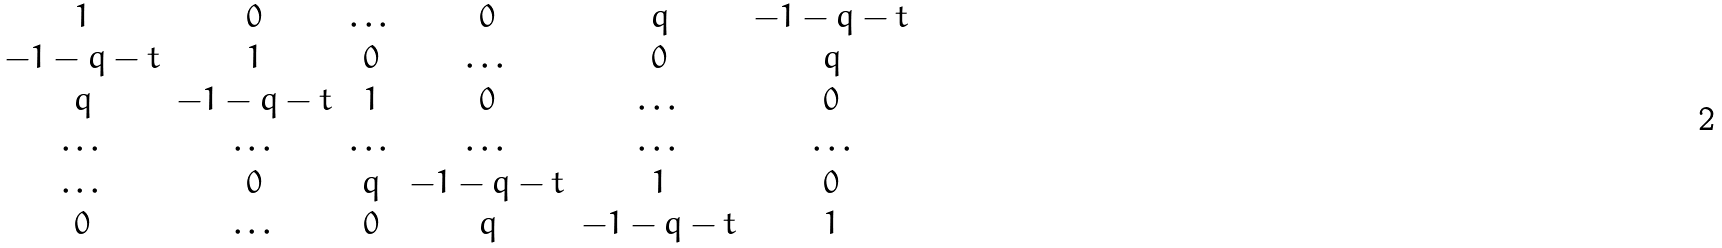<formula> <loc_0><loc_0><loc_500><loc_500>\begin{matrix} 1 & 0 & \dots & 0 & q & - 1 - q - t \\ - 1 - q - t & 1 & 0 & \dots & 0 & q \\ q & - 1 - q - t & 1 & 0 & \dots & 0 \\ \dots & \dots & \dots & \dots & \dots & \dots \\ \dots & 0 & q & - 1 - q - t & 1 & 0 \\ 0 & \dots & 0 & q & - 1 - q - t & 1 \end{matrix}</formula> 